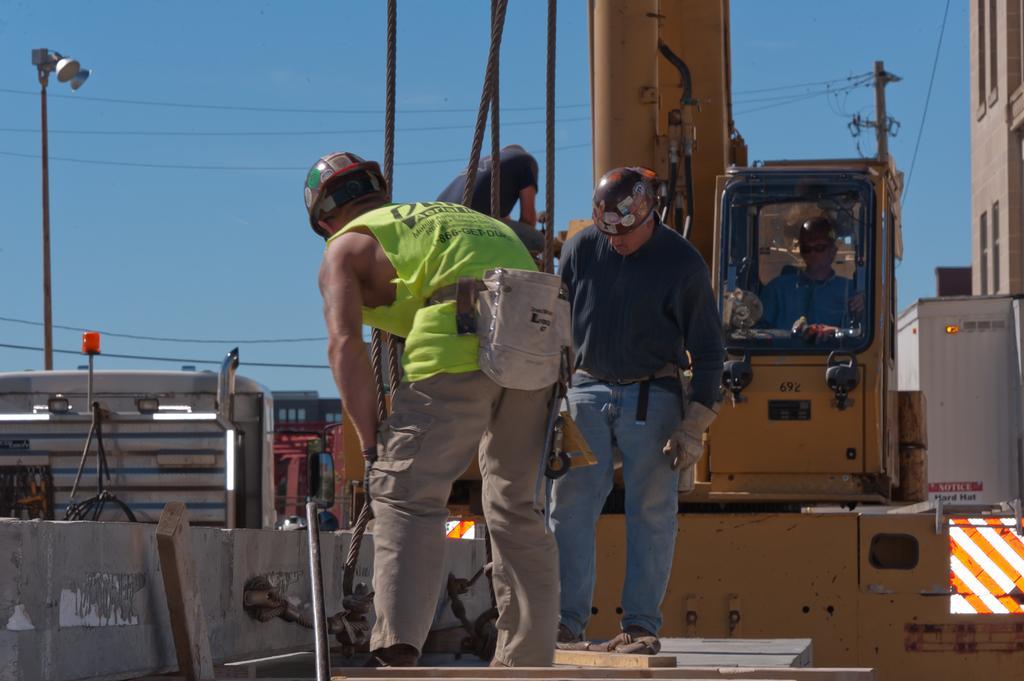Can you describe this image briefly? In this image two people are standing on an object which is tied with ropes. They are wearing helmets. A person is sitting in the vehicle. He is wearing goggles and cap. A person is standing on the vehicle. Left side there is a wall. Behind there are vehicles and few objects on the floor. Right side there is a building. Before it there is a pole connected with wires. Left side there is a street light. Top of the image there is sky. 